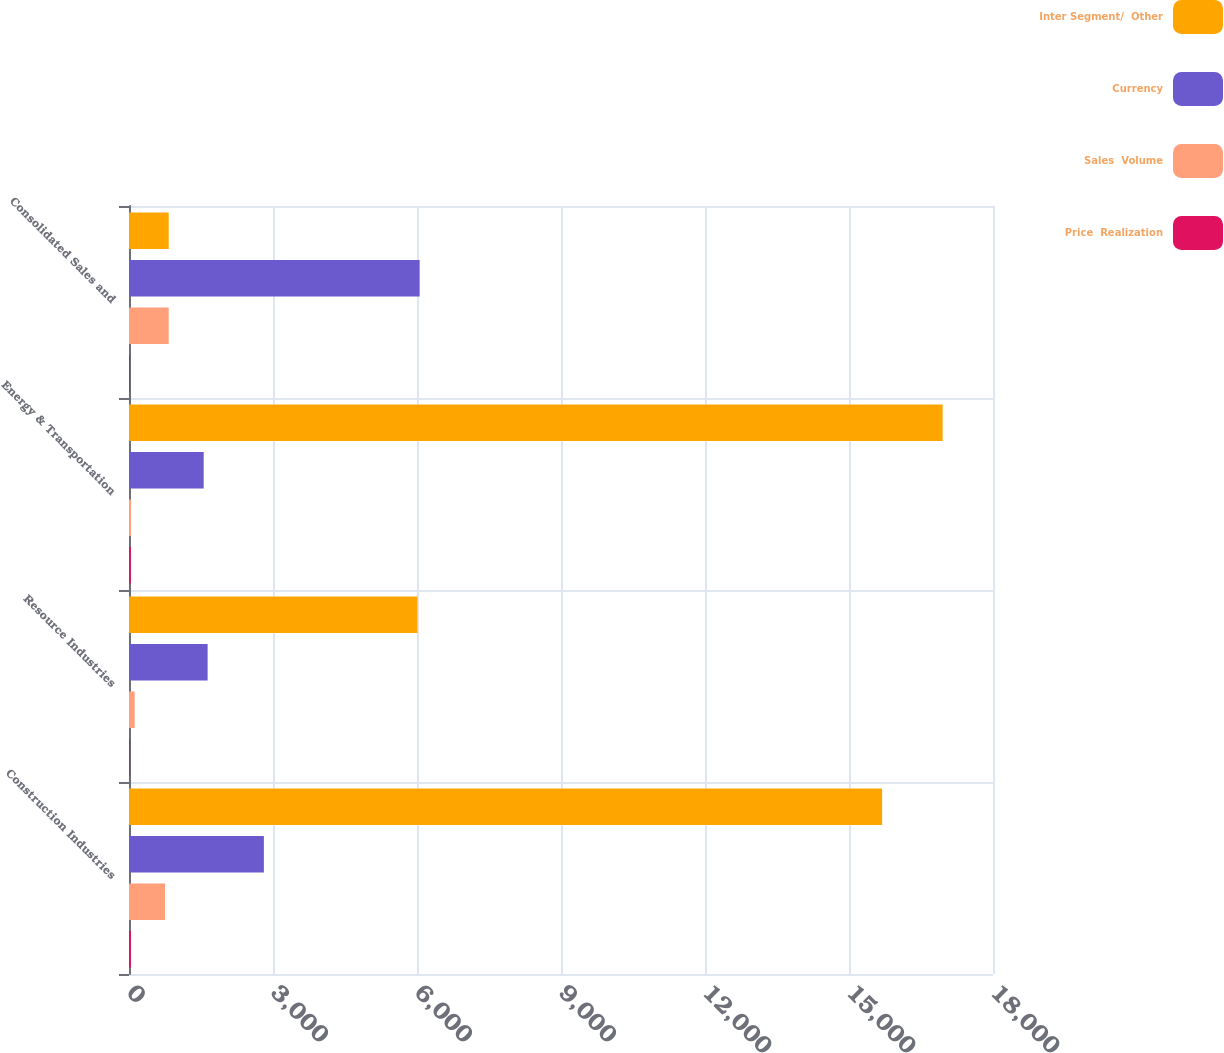Convert chart to OTSL. <chart><loc_0><loc_0><loc_500><loc_500><stacked_bar_chart><ecel><fcel>Construction Industries<fcel>Resource Industries<fcel>Energy & Transportation<fcel>Consolidated Sales and<nl><fcel>Inter Segment/  Other<fcel>15690<fcel>6010<fcel>16951<fcel>827<nl><fcel>Currency<fcel>2810<fcel>1638<fcel>1556<fcel>6055<nl><fcel>Sales  Volume<fcel>751<fcel>118<fcel>42<fcel>827<nl><fcel>Price  Realization<fcel>40<fcel>22<fcel>39<fcel>21<nl></chart> 